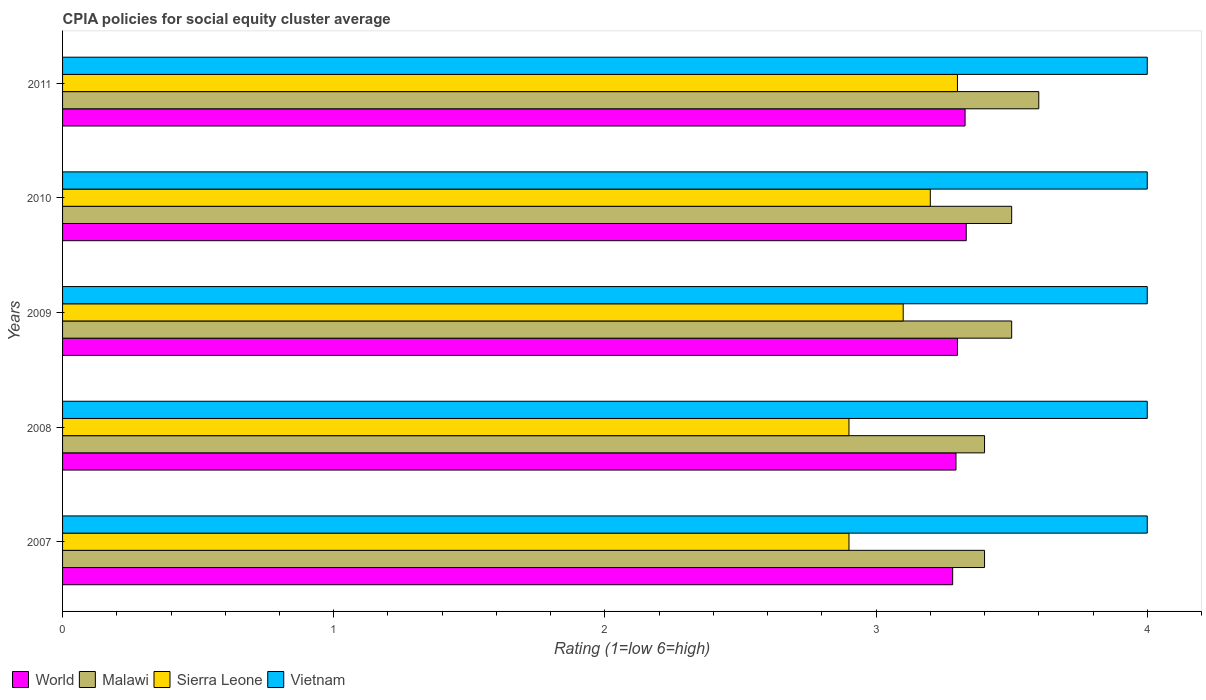How many different coloured bars are there?
Your answer should be very brief. 4. Are the number of bars per tick equal to the number of legend labels?
Provide a short and direct response. Yes. How many bars are there on the 1st tick from the bottom?
Give a very brief answer. 4. What is the label of the 1st group of bars from the top?
Make the answer very short. 2011. In how many cases, is the number of bars for a given year not equal to the number of legend labels?
Ensure brevity in your answer.  0. What is the CPIA rating in Vietnam in 2008?
Provide a succinct answer. 4. Across all years, what is the maximum CPIA rating in Malawi?
Offer a very short reply. 3.6. In which year was the CPIA rating in World minimum?
Your response must be concise. 2007. What is the total CPIA rating in World in the graph?
Provide a short and direct response. 16.54. What is the difference between the CPIA rating in World in 2008 and that in 2009?
Ensure brevity in your answer.  -0.01. What is the difference between the CPIA rating in World in 2011 and the CPIA rating in Vietnam in 2008?
Your answer should be compact. -0.67. What is the average CPIA rating in Sierra Leone per year?
Provide a succinct answer. 3.08. In the year 2010, what is the difference between the CPIA rating in Malawi and CPIA rating in World?
Ensure brevity in your answer.  0.17. In how many years, is the CPIA rating in Vietnam greater than 0.6000000000000001 ?
Offer a very short reply. 5. What is the ratio of the CPIA rating in Vietnam in 2007 to that in 2010?
Your answer should be compact. 1. Is the difference between the CPIA rating in Malawi in 2010 and 2011 greater than the difference between the CPIA rating in World in 2010 and 2011?
Give a very brief answer. No. What is the difference between the highest and the second highest CPIA rating in Sierra Leone?
Offer a terse response. 0.1. What is the difference between the highest and the lowest CPIA rating in Vietnam?
Ensure brevity in your answer.  0. In how many years, is the CPIA rating in World greater than the average CPIA rating in World taken over all years?
Provide a succinct answer. 2. Is the sum of the CPIA rating in World in 2007 and 2010 greater than the maximum CPIA rating in Sierra Leone across all years?
Offer a very short reply. Yes. What does the 3rd bar from the top in 2011 represents?
Provide a succinct answer. Malawi. What does the 3rd bar from the bottom in 2009 represents?
Keep it short and to the point. Sierra Leone. Is it the case that in every year, the sum of the CPIA rating in Sierra Leone and CPIA rating in Malawi is greater than the CPIA rating in Vietnam?
Your answer should be compact. Yes. How many bars are there?
Keep it short and to the point. 20. Are all the bars in the graph horizontal?
Provide a succinct answer. Yes. How many years are there in the graph?
Give a very brief answer. 5. What is the difference between two consecutive major ticks on the X-axis?
Provide a succinct answer. 1. Does the graph contain any zero values?
Provide a succinct answer. No. Where does the legend appear in the graph?
Ensure brevity in your answer.  Bottom left. How many legend labels are there?
Keep it short and to the point. 4. How are the legend labels stacked?
Provide a succinct answer. Horizontal. What is the title of the graph?
Provide a short and direct response. CPIA policies for social equity cluster average. What is the label or title of the Y-axis?
Offer a terse response. Years. What is the Rating (1=low 6=high) of World in 2007?
Your answer should be compact. 3.28. What is the Rating (1=low 6=high) of Sierra Leone in 2007?
Provide a succinct answer. 2.9. What is the Rating (1=low 6=high) of World in 2008?
Provide a short and direct response. 3.29. What is the Rating (1=low 6=high) in Sierra Leone in 2008?
Your answer should be compact. 2.9. What is the Rating (1=low 6=high) of Vietnam in 2008?
Offer a terse response. 4. What is the Rating (1=low 6=high) in World in 2009?
Make the answer very short. 3.3. What is the Rating (1=low 6=high) in Malawi in 2009?
Make the answer very short. 3.5. What is the Rating (1=low 6=high) of World in 2010?
Provide a short and direct response. 3.33. What is the Rating (1=low 6=high) in Malawi in 2010?
Your answer should be compact. 3.5. What is the Rating (1=low 6=high) in World in 2011?
Provide a short and direct response. 3.33. What is the Rating (1=low 6=high) of Malawi in 2011?
Make the answer very short. 3.6. What is the Rating (1=low 6=high) in Vietnam in 2011?
Offer a terse response. 4. Across all years, what is the maximum Rating (1=low 6=high) of World?
Ensure brevity in your answer.  3.33. Across all years, what is the maximum Rating (1=low 6=high) of Malawi?
Provide a succinct answer. 3.6. Across all years, what is the maximum Rating (1=low 6=high) of Sierra Leone?
Provide a succinct answer. 3.3. Across all years, what is the minimum Rating (1=low 6=high) of World?
Offer a very short reply. 3.28. What is the total Rating (1=low 6=high) of World in the graph?
Offer a terse response. 16.54. What is the total Rating (1=low 6=high) of Malawi in the graph?
Offer a very short reply. 17.4. What is the total Rating (1=low 6=high) of Vietnam in the graph?
Keep it short and to the point. 20. What is the difference between the Rating (1=low 6=high) of World in 2007 and that in 2008?
Give a very brief answer. -0.01. What is the difference between the Rating (1=low 6=high) in World in 2007 and that in 2009?
Your response must be concise. -0.02. What is the difference between the Rating (1=low 6=high) of Malawi in 2007 and that in 2009?
Keep it short and to the point. -0.1. What is the difference between the Rating (1=low 6=high) of Sierra Leone in 2007 and that in 2009?
Offer a very short reply. -0.2. What is the difference between the Rating (1=low 6=high) in Vietnam in 2007 and that in 2009?
Keep it short and to the point. 0. What is the difference between the Rating (1=low 6=high) in Malawi in 2007 and that in 2010?
Provide a succinct answer. -0.1. What is the difference between the Rating (1=low 6=high) of Sierra Leone in 2007 and that in 2010?
Keep it short and to the point. -0.3. What is the difference between the Rating (1=low 6=high) of Vietnam in 2007 and that in 2010?
Your answer should be compact. 0. What is the difference between the Rating (1=low 6=high) of World in 2007 and that in 2011?
Make the answer very short. -0.05. What is the difference between the Rating (1=low 6=high) in Sierra Leone in 2007 and that in 2011?
Your answer should be very brief. -0.4. What is the difference between the Rating (1=low 6=high) in World in 2008 and that in 2009?
Keep it short and to the point. -0.01. What is the difference between the Rating (1=low 6=high) of Sierra Leone in 2008 and that in 2009?
Offer a very short reply. -0.2. What is the difference between the Rating (1=low 6=high) in Vietnam in 2008 and that in 2009?
Offer a very short reply. 0. What is the difference between the Rating (1=low 6=high) in World in 2008 and that in 2010?
Ensure brevity in your answer.  -0.04. What is the difference between the Rating (1=low 6=high) in Malawi in 2008 and that in 2010?
Make the answer very short. -0.1. What is the difference between the Rating (1=low 6=high) of World in 2008 and that in 2011?
Ensure brevity in your answer.  -0.03. What is the difference between the Rating (1=low 6=high) in World in 2009 and that in 2010?
Give a very brief answer. -0.03. What is the difference between the Rating (1=low 6=high) in Sierra Leone in 2009 and that in 2010?
Your answer should be very brief. -0.1. What is the difference between the Rating (1=low 6=high) of Vietnam in 2009 and that in 2010?
Offer a very short reply. 0. What is the difference between the Rating (1=low 6=high) in World in 2009 and that in 2011?
Provide a short and direct response. -0.03. What is the difference between the Rating (1=low 6=high) in Malawi in 2009 and that in 2011?
Your answer should be compact. -0.1. What is the difference between the Rating (1=low 6=high) of Sierra Leone in 2009 and that in 2011?
Your answer should be compact. -0.2. What is the difference between the Rating (1=low 6=high) in World in 2010 and that in 2011?
Give a very brief answer. 0. What is the difference between the Rating (1=low 6=high) in Malawi in 2010 and that in 2011?
Your answer should be very brief. -0.1. What is the difference between the Rating (1=low 6=high) in World in 2007 and the Rating (1=low 6=high) in Malawi in 2008?
Make the answer very short. -0.12. What is the difference between the Rating (1=low 6=high) in World in 2007 and the Rating (1=low 6=high) in Sierra Leone in 2008?
Your answer should be very brief. 0.38. What is the difference between the Rating (1=low 6=high) in World in 2007 and the Rating (1=low 6=high) in Vietnam in 2008?
Your answer should be compact. -0.72. What is the difference between the Rating (1=low 6=high) of Malawi in 2007 and the Rating (1=low 6=high) of Sierra Leone in 2008?
Give a very brief answer. 0.5. What is the difference between the Rating (1=low 6=high) in Malawi in 2007 and the Rating (1=low 6=high) in Vietnam in 2008?
Keep it short and to the point. -0.6. What is the difference between the Rating (1=low 6=high) in Sierra Leone in 2007 and the Rating (1=low 6=high) in Vietnam in 2008?
Offer a very short reply. -1.1. What is the difference between the Rating (1=low 6=high) of World in 2007 and the Rating (1=low 6=high) of Malawi in 2009?
Give a very brief answer. -0.22. What is the difference between the Rating (1=low 6=high) in World in 2007 and the Rating (1=low 6=high) in Sierra Leone in 2009?
Make the answer very short. 0.18. What is the difference between the Rating (1=low 6=high) of World in 2007 and the Rating (1=low 6=high) of Vietnam in 2009?
Your answer should be compact. -0.72. What is the difference between the Rating (1=low 6=high) of Malawi in 2007 and the Rating (1=low 6=high) of Sierra Leone in 2009?
Ensure brevity in your answer.  0.3. What is the difference between the Rating (1=low 6=high) of World in 2007 and the Rating (1=low 6=high) of Malawi in 2010?
Make the answer very short. -0.22. What is the difference between the Rating (1=low 6=high) of World in 2007 and the Rating (1=low 6=high) of Sierra Leone in 2010?
Make the answer very short. 0.08. What is the difference between the Rating (1=low 6=high) of World in 2007 and the Rating (1=low 6=high) of Vietnam in 2010?
Give a very brief answer. -0.72. What is the difference between the Rating (1=low 6=high) in Malawi in 2007 and the Rating (1=low 6=high) in Sierra Leone in 2010?
Keep it short and to the point. 0.2. What is the difference between the Rating (1=low 6=high) in Sierra Leone in 2007 and the Rating (1=low 6=high) in Vietnam in 2010?
Provide a short and direct response. -1.1. What is the difference between the Rating (1=low 6=high) of World in 2007 and the Rating (1=low 6=high) of Malawi in 2011?
Give a very brief answer. -0.32. What is the difference between the Rating (1=low 6=high) in World in 2007 and the Rating (1=low 6=high) in Sierra Leone in 2011?
Make the answer very short. -0.02. What is the difference between the Rating (1=low 6=high) of World in 2007 and the Rating (1=low 6=high) of Vietnam in 2011?
Keep it short and to the point. -0.72. What is the difference between the Rating (1=low 6=high) in Malawi in 2007 and the Rating (1=low 6=high) in Sierra Leone in 2011?
Provide a short and direct response. 0.1. What is the difference between the Rating (1=low 6=high) in Sierra Leone in 2007 and the Rating (1=low 6=high) in Vietnam in 2011?
Ensure brevity in your answer.  -1.1. What is the difference between the Rating (1=low 6=high) of World in 2008 and the Rating (1=low 6=high) of Malawi in 2009?
Make the answer very short. -0.21. What is the difference between the Rating (1=low 6=high) of World in 2008 and the Rating (1=low 6=high) of Sierra Leone in 2009?
Your response must be concise. 0.19. What is the difference between the Rating (1=low 6=high) in World in 2008 and the Rating (1=low 6=high) in Vietnam in 2009?
Ensure brevity in your answer.  -0.71. What is the difference between the Rating (1=low 6=high) of Malawi in 2008 and the Rating (1=low 6=high) of Sierra Leone in 2009?
Provide a short and direct response. 0.3. What is the difference between the Rating (1=low 6=high) of Sierra Leone in 2008 and the Rating (1=low 6=high) of Vietnam in 2009?
Your response must be concise. -1.1. What is the difference between the Rating (1=low 6=high) in World in 2008 and the Rating (1=low 6=high) in Malawi in 2010?
Make the answer very short. -0.21. What is the difference between the Rating (1=low 6=high) in World in 2008 and the Rating (1=low 6=high) in Sierra Leone in 2010?
Provide a short and direct response. 0.09. What is the difference between the Rating (1=low 6=high) in World in 2008 and the Rating (1=low 6=high) in Vietnam in 2010?
Make the answer very short. -0.71. What is the difference between the Rating (1=low 6=high) of Malawi in 2008 and the Rating (1=low 6=high) of Vietnam in 2010?
Make the answer very short. -0.6. What is the difference between the Rating (1=low 6=high) of World in 2008 and the Rating (1=low 6=high) of Malawi in 2011?
Ensure brevity in your answer.  -0.31. What is the difference between the Rating (1=low 6=high) of World in 2008 and the Rating (1=low 6=high) of Sierra Leone in 2011?
Your answer should be compact. -0.01. What is the difference between the Rating (1=low 6=high) in World in 2008 and the Rating (1=low 6=high) in Vietnam in 2011?
Your response must be concise. -0.71. What is the difference between the Rating (1=low 6=high) of World in 2009 and the Rating (1=low 6=high) of Malawi in 2010?
Ensure brevity in your answer.  -0.2. What is the difference between the Rating (1=low 6=high) of World in 2009 and the Rating (1=low 6=high) of Sierra Leone in 2010?
Your answer should be very brief. 0.1. What is the difference between the Rating (1=low 6=high) of World in 2009 and the Rating (1=low 6=high) of Vietnam in 2010?
Your answer should be compact. -0.7. What is the difference between the Rating (1=low 6=high) of Malawi in 2009 and the Rating (1=low 6=high) of Sierra Leone in 2010?
Provide a short and direct response. 0.3. What is the difference between the Rating (1=low 6=high) of Malawi in 2009 and the Rating (1=low 6=high) of Vietnam in 2010?
Keep it short and to the point. -0.5. What is the difference between the Rating (1=low 6=high) of Sierra Leone in 2009 and the Rating (1=low 6=high) of Vietnam in 2010?
Your answer should be very brief. -0.9. What is the difference between the Rating (1=low 6=high) of World in 2009 and the Rating (1=low 6=high) of Malawi in 2011?
Provide a succinct answer. -0.3. What is the difference between the Rating (1=low 6=high) of Sierra Leone in 2009 and the Rating (1=low 6=high) of Vietnam in 2011?
Your answer should be very brief. -0.9. What is the difference between the Rating (1=low 6=high) of World in 2010 and the Rating (1=low 6=high) of Malawi in 2011?
Your response must be concise. -0.27. What is the difference between the Rating (1=low 6=high) in World in 2010 and the Rating (1=low 6=high) in Sierra Leone in 2011?
Offer a terse response. 0.03. What is the difference between the Rating (1=low 6=high) of World in 2010 and the Rating (1=low 6=high) of Vietnam in 2011?
Your answer should be very brief. -0.67. What is the difference between the Rating (1=low 6=high) of Malawi in 2010 and the Rating (1=low 6=high) of Sierra Leone in 2011?
Your answer should be compact. 0.2. What is the difference between the Rating (1=low 6=high) of Malawi in 2010 and the Rating (1=low 6=high) of Vietnam in 2011?
Keep it short and to the point. -0.5. What is the difference between the Rating (1=low 6=high) in Sierra Leone in 2010 and the Rating (1=low 6=high) in Vietnam in 2011?
Give a very brief answer. -0.8. What is the average Rating (1=low 6=high) of World per year?
Provide a short and direct response. 3.31. What is the average Rating (1=low 6=high) in Malawi per year?
Keep it short and to the point. 3.48. What is the average Rating (1=low 6=high) of Sierra Leone per year?
Provide a short and direct response. 3.08. In the year 2007, what is the difference between the Rating (1=low 6=high) in World and Rating (1=low 6=high) in Malawi?
Make the answer very short. -0.12. In the year 2007, what is the difference between the Rating (1=low 6=high) in World and Rating (1=low 6=high) in Sierra Leone?
Offer a very short reply. 0.38. In the year 2007, what is the difference between the Rating (1=low 6=high) in World and Rating (1=low 6=high) in Vietnam?
Your answer should be compact. -0.72. In the year 2007, what is the difference between the Rating (1=low 6=high) of Malawi and Rating (1=low 6=high) of Sierra Leone?
Offer a terse response. 0.5. In the year 2008, what is the difference between the Rating (1=low 6=high) in World and Rating (1=low 6=high) in Malawi?
Keep it short and to the point. -0.11. In the year 2008, what is the difference between the Rating (1=low 6=high) in World and Rating (1=low 6=high) in Sierra Leone?
Provide a short and direct response. 0.39. In the year 2008, what is the difference between the Rating (1=low 6=high) of World and Rating (1=low 6=high) of Vietnam?
Your answer should be compact. -0.71. In the year 2008, what is the difference between the Rating (1=low 6=high) in Malawi and Rating (1=low 6=high) in Vietnam?
Offer a terse response. -0.6. In the year 2009, what is the difference between the Rating (1=low 6=high) in World and Rating (1=low 6=high) in Malawi?
Offer a very short reply. -0.2. In the year 2009, what is the difference between the Rating (1=low 6=high) in World and Rating (1=low 6=high) in Sierra Leone?
Provide a short and direct response. 0.2. In the year 2010, what is the difference between the Rating (1=low 6=high) of World and Rating (1=low 6=high) of Malawi?
Ensure brevity in your answer.  -0.17. In the year 2010, what is the difference between the Rating (1=low 6=high) in World and Rating (1=low 6=high) in Sierra Leone?
Offer a terse response. 0.13. In the year 2010, what is the difference between the Rating (1=low 6=high) of World and Rating (1=low 6=high) of Vietnam?
Ensure brevity in your answer.  -0.67. In the year 2011, what is the difference between the Rating (1=low 6=high) in World and Rating (1=low 6=high) in Malawi?
Provide a succinct answer. -0.27. In the year 2011, what is the difference between the Rating (1=low 6=high) of World and Rating (1=low 6=high) of Sierra Leone?
Provide a succinct answer. 0.03. In the year 2011, what is the difference between the Rating (1=low 6=high) of World and Rating (1=low 6=high) of Vietnam?
Your response must be concise. -0.67. In the year 2011, what is the difference between the Rating (1=low 6=high) in Malawi and Rating (1=low 6=high) in Sierra Leone?
Offer a terse response. 0.3. In the year 2011, what is the difference between the Rating (1=low 6=high) of Malawi and Rating (1=low 6=high) of Vietnam?
Offer a terse response. -0.4. What is the ratio of the Rating (1=low 6=high) of World in 2007 to that in 2008?
Keep it short and to the point. 1. What is the ratio of the Rating (1=low 6=high) of Malawi in 2007 to that in 2008?
Your answer should be compact. 1. What is the ratio of the Rating (1=low 6=high) of Vietnam in 2007 to that in 2008?
Offer a very short reply. 1. What is the ratio of the Rating (1=low 6=high) in Malawi in 2007 to that in 2009?
Give a very brief answer. 0.97. What is the ratio of the Rating (1=low 6=high) in Sierra Leone in 2007 to that in 2009?
Your answer should be compact. 0.94. What is the ratio of the Rating (1=low 6=high) of World in 2007 to that in 2010?
Offer a terse response. 0.98. What is the ratio of the Rating (1=low 6=high) in Malawi in 2007 to that in 2010?
Provide a short and direct response. 0.97. What is the ratio of the Rating (1=low 6=high) in Sierra Leone in 2007 to that in 2010?
Give a very brief answer. 0.91. What is the ratio of the Rating (1=low 6=high) in World in 2007 to that in 2011?
Give a very brief answer. 0.99. What is the ratio of the Rating (1=low 6=high) of Sierra Leone in 2007 to that in 2011?
Provide a short and direct response. 0.88. What is the ratio of the Rating (1=low 6=high) of Vietnam in 2007 to that in 2011?
Offer a very short reply. 1. What is the ratio of the Rating (1=low 6=high) in World in 2008 to that in 2009?
Keep it short and to the point. 1. What is the ratio of the Rating (1=low 6=high) of Malawi in 2008 to that in 2009?
Ensure brevity in your answer.  0.97. What is the ratio of the Rating (1=low 6=high) in Sierra Leone in 2008 to that in 2009?
Make the answer very short. 0.94. What is the ratio of the Rating (1=low 6=high) in Vietnam in 2008 to that in 2009?
Your response must be concise. 1. What is the ratio of the Rating (1=low 6=high) in World in 2008 to that in 2010?
Your response must be concise. 0.99. What is the ratio of the Rating (1=low 6=high) of Malawi in 2008 to that in 2010?
Your response must be concise. 0.97. What is the ratio of the Rating (1=low 6=high) of Sierra Leone in 2008 to that in 2010?
Ensure brevity in your answer.  0.91. What is the ratio of the Rating (1=low 6=high) of World in 2008 to that in 2011?
Offer a very short reply. 0.99. What is the ratio of the Rating (1=low 6=high) in Sierra Leone in 2008 to that in 2011?
Provide a succinct answer. 0.88. What is the ratio of the Rating (1=low 6=high) of World in 2009 to that in 2010?
Make the answer very short. 0.99. What is the ratio of the Rating (1=low 6=high) in Malawi in 2009 to that in 2010?
Provide a succinct answer. 1. What is the ratio of the Rating (1=low 6=high) in Sierra Leone in 2009 to that in 2010?
Your answer should be compact. 0.97. What is the ratio of the Rating (1=low 6=high) in Vietnam in 2009 to that in 2010?
Ensure brevity in your answer.  1. What is the ratio of the Rating (1=low 6=high) in Malawi in 2009 to that in 2011?
Offer a very short reply. 0.97. What is the ratio of the Rating (1=low 6=high) of Sierra Leone in 2009 to that in 2011?
Offer a very short reply. 0.94. What is the ratio of the Rating (1=low 6=high) of Vietnam in 2009 to that in 2011?
Your answer should be compact. 1. What is the ratio of the Rating (1=low 6=high) in World in 2010 to that in 2011?
Make the answer very short. 1. What is the ratio of the Rating (1=low 6=high) of Malawi in 2010 to that in 2011?
Your answer should be very brief. 0.97. What is the ratio of the Rating (1=low 6=high) of Sierra Leone in 2010 to that in 2011?
Offer a very short reply. 0.97. What is the ratio of the Rating (1=low 6=high) of Vietnam in 2010 to that in 2011?
Offer a very short reply. 1. What is the difference between the highest and the second highest Rating (1=low 6=high) in World?
Make the answer very short. 0. What is the difference between the highest and the second highest Rating (1=low 6=high) of Malawi?
Make the answer very short. 0.1. What is the difference between the highest and the second highest Rating (1=low 6=high) in Vietnam?
Give a very brief answer. 0. What is the difference between the highest and the lowest Rating (1=low 6=high) in World?
Your response must be concise. 0.05. What is the difference between the highest and the lowest Rating (1=low 6=high) in Malawi?
Your answer should be compact. 0.2. What is the difference between the highest and the lowest Rating (1=low 6=high) of Vietnam?
Provide a short and direct response. 0. 